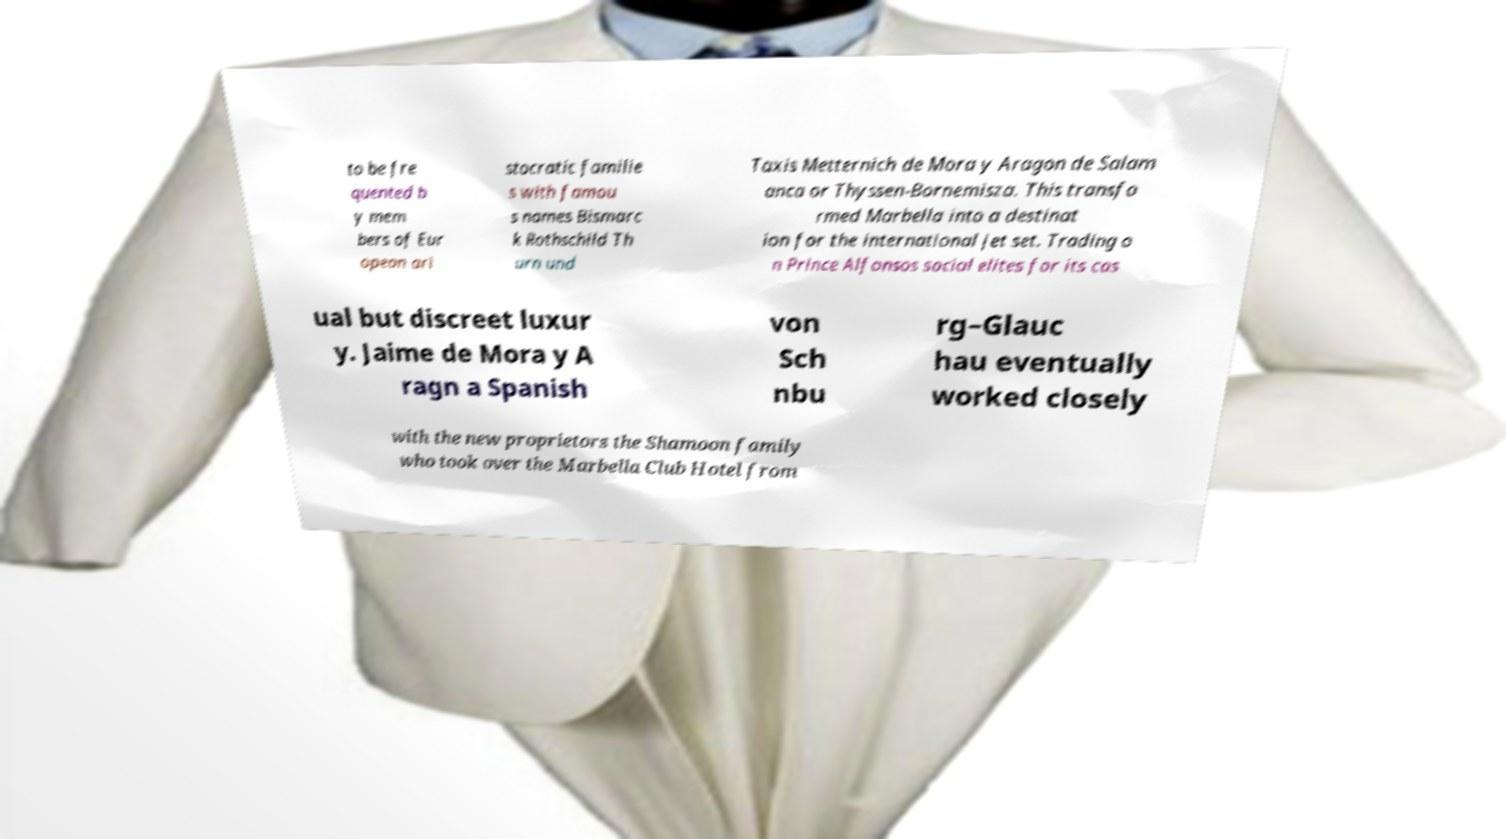Can you accurately transcribe the text from the provided image for me? to be fre quented b y mem bers of Eur opean ari stocratic familie s with famou s names Bismarc k Rothschild Th urn und Taxis Metternich de Mora y Aragon de Salam anca or Thyssen-Bornemisza. This transfo rmed Marbella into a destinat ion for the international jet set. Trading o n Prince Alfonsos social elites for its cas ual but discreet luxur y. Jaime de Mora y A ragn a Spanish von Sch nbu rg–Glauc hau eventually worked closely with the new proprietors the Shamoon family who took over the Marbella Club Hotel from 